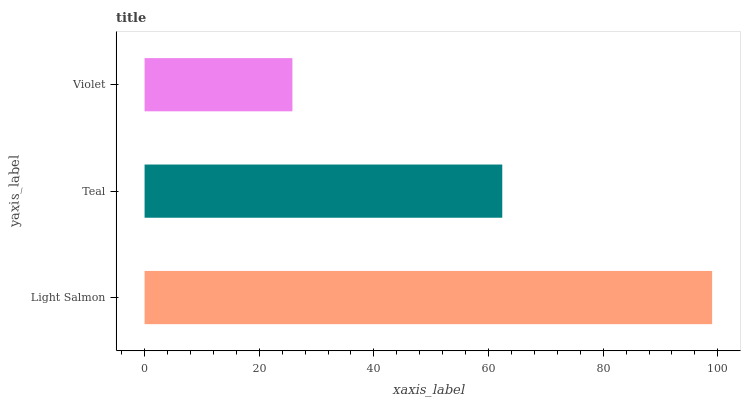Is Violet the minimum?
Answer yes or no. Yes. Is Light Salmon the maximum?
Answer yes or no. Yes. Is Teal the minimum?
Answer yes or no. No. Is Teal the maximum?
Answer yes or no. No. Is Light Salmon greater than Teal?
Answer yes or no. Yes. Is Teal less than Light Salmon?
Answer yes or no. Yes. Is Teal greater than Light Salmon?
Answer yes or no. No. Is Light Salmon less than Teal?
Answer yes or no. No. Is Teal the high median?
Answer yes or no. Yes. Is Teal the low median?
Answer yes or no. Yes. Is Light Salmon the high median?
Answer yes or no. No. Is Light Salmon the low median?
Answer yes or no. No. 